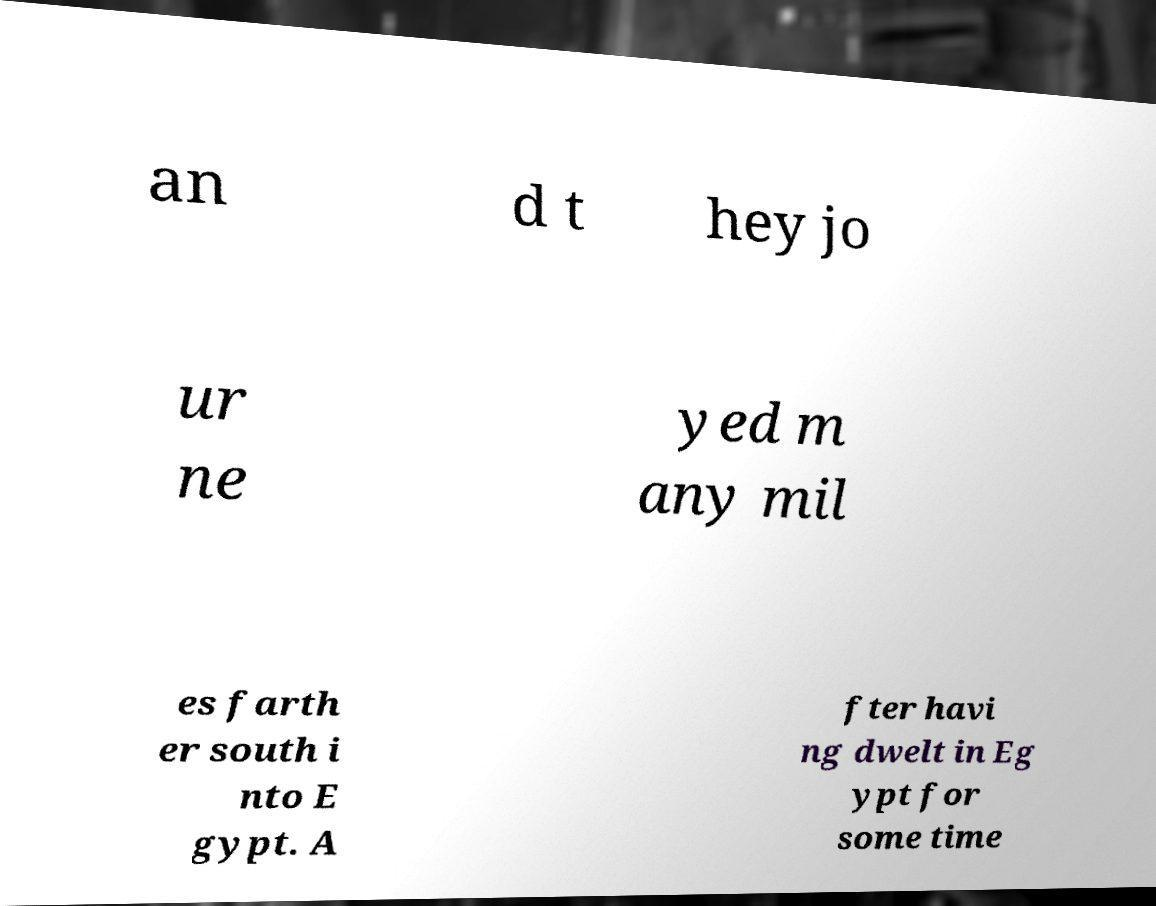Could you extract and type out the text from this image? an d t hey jo ur ne yed m any mil es farth er south i nto E gypt. A fter havi ng dwelt in Eg ypt for some time 